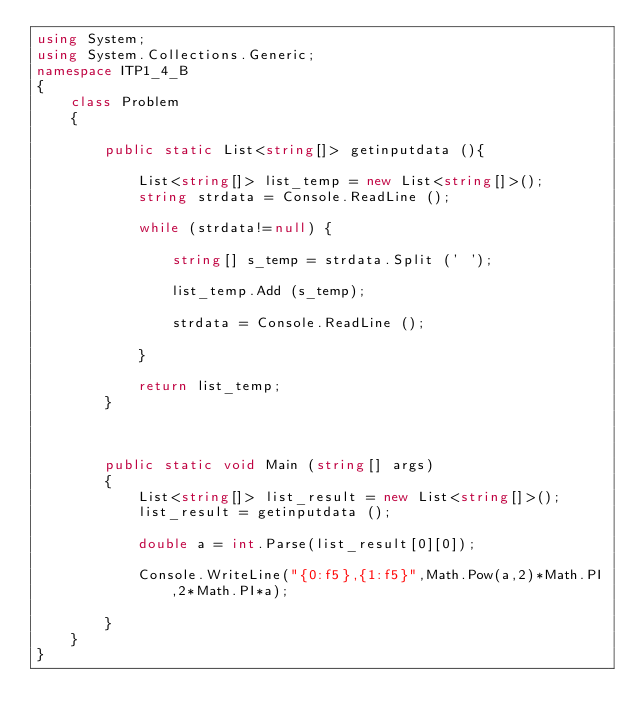Convert code to text. <code><loc_0><loc_0><loc_500><loc_500><_C#_>using System;
using System.Collections.Generic;
namespace ITP1_4_B
{
    class Problem
    {

        public static List<string[]> getinputdata (){

            List<string[]> list_temp = new List<string[]>();
            string strdata = Console.ReadLine ();

            while (strdata!=null) {

                string[] s_temp = strdata.Split (' ');

                list_temp.Add (s_temp);

                strdata = Console.ReadLine ();

            }

            return list_temp;
        }



        public static void Main (string[] args)
        {
            List<string[]> list_result = new List<string[]>();
            list_result = getinputdata ();

            double a = int.Parse(list_result[0][0]);

            Console.WriteLine("{0:f5},{1:f5}",Math.Pow(a,2)*Math.PI,2*Math.PI*a);

        }
    }
}</code> 